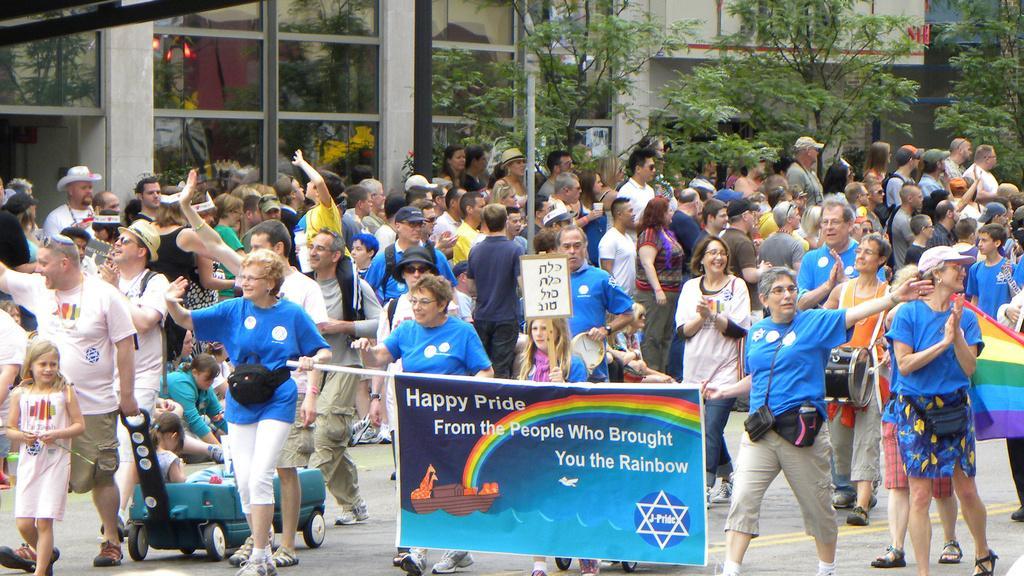Can you describe this image briefly? In this image there are persons standing and walking. In the front there are persons holding banner with some text written on it. In the background there are buildings and trees. In the center there is a pole. 